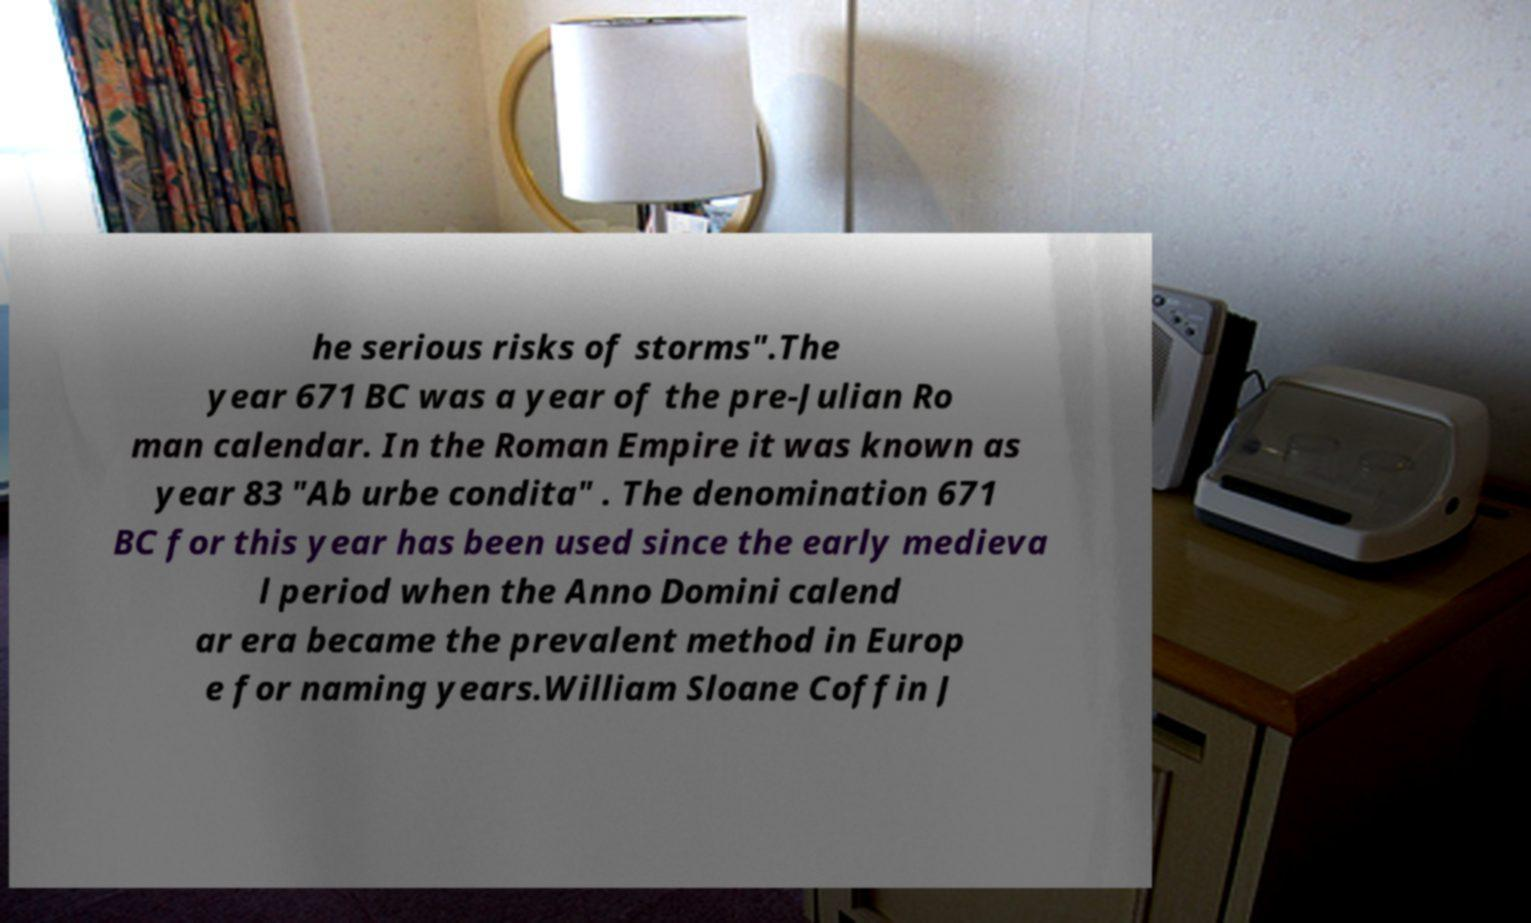What messages or text are displayed in this image? I need them in a readable, typed format. he serious risks of storms".The year 671 BC was a year of the pre-Julian Ro man calendar. In the Roman Empire it was known as year 83 "Ab urbe condita" . The denomination 671 BC for this year has been used since the early medieva l period when the Anno Domini calend ar era became the prevalent method in Europ e for naming years.William Sloane Coffin J 